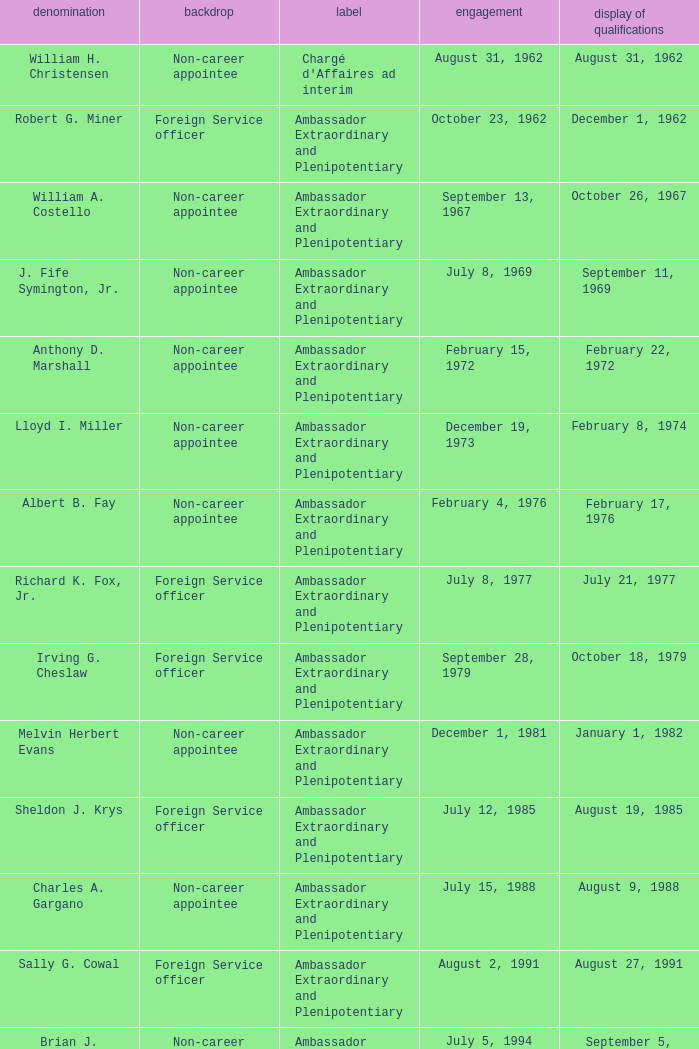When did Robert G. Miner present his credentials? December 1, 1962. 